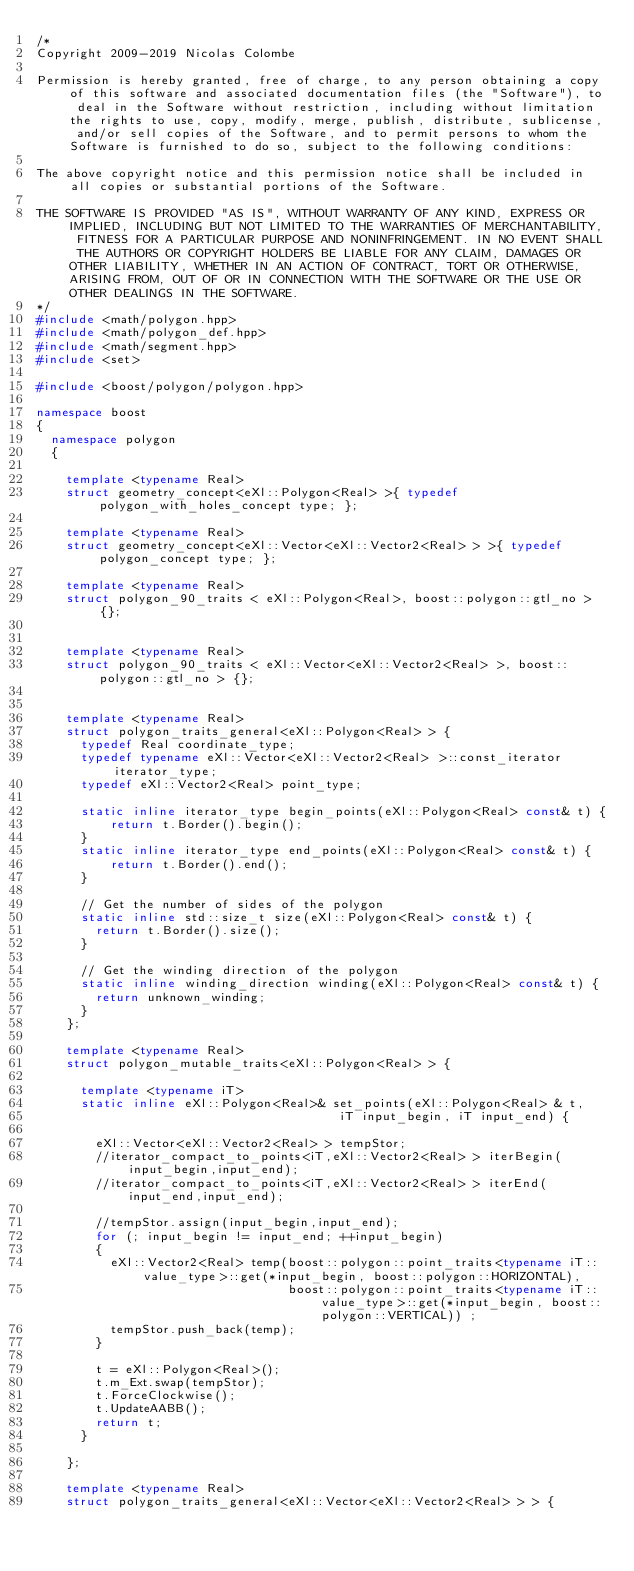Convert code to text. <code><loc_0><loc_0><loc_500><loc_500><_C++_>/*
Copyright 2009-2019 Nicolas Colombe

Permission is hereby granted, free of charge, to any person obtaining a copy of this software and associated documentation files (the "Software"), to deal in the Software without restriction, including without limitation the rights to use, copy, modify, merge, publish, distribute, sublicense, and/or sell copies of the Software, and to permit persons to whom the Software is furnished to do so, subject to the following conditions:

The above copyright notice and this permission notice shall be included in all copies or substantial portions of the Software.

THE SOFTWARE IS PROVIDED "AS IS", WITHOUT WARRANTY OF ANY KIND, EXPRESS OR IMPLIED, INCLUDING BUT NOT LIMITED TO THE WARRANTIES OF MERCHANTABILITY, FITNESS FOR A PARTICULAR PURPOSE AND NONINFRINGEMENT. IN NO EVENT SHALL THE AUTHORS OR COPYRIGHT HOLDERS BE LIABLE FOR ANY CLAIM, DAMAGES OR OTHER LIABILITY, WHETHER IN AN ACTION OF CONTRACT, TORT OR OTHERWISE, ARISING FROM, OUT OF OR IN CONNECTION WITH THE SOFTWARE OR THE USE OR OTHER DEALINGS IN THE SOFTWARE.
*/
#include <math/polygon.hpp>
#include <math/polygon_def.hpp>
#include <math/segment.hpp>
#include <set>

#include <boost/polygon/polygon.hpp>

namespace boost
{
  namespace polygon 
  {
  
    template <typename Real>
    struct geometry_concept<eXl::Polygon<Real> >{ typedef polygon_with_holes_concept type; };
  
    template <typename Real>
    struct geometry_concept<eXl::Vector<eXl::Vector2<Real> > >{ typedef polygon_concept type; };
  
    template <typename Real>
    struct polygon_90_traits < eXl::Polygon<Real>, boost::polygon::gtl_no > {};
    
  
    template <typename Real>
    struct polygon_90_traits < eXl::Vector<eXl::Vector2<Real> >, boost::polygon::gtl_no > {};
    
  
    template <typename Real>
    struct polygon_traits_general<eXl::Polygon<Real> > {
      typedef Real coordinate_type;
      typedef typename eXl::Vector<eXl::Vector2<Real> >::const_iterator iterator_type;
      typedef eXl::Vector2<Real> point_type;
    
      static inline iterator_type begin_points(eXl::Polygon<Real> const& t) {
          return t.Border().begin();
      }
      static inline iterator_type end_points(eXl::Polygon<Real> const& t) {
          return t.Border().end();
      }
    
      // Get the number of sides of the polygon
      static inline std::size_t size(eXl::Polygon<Real> const& t) {
        return t.Border().size();
      }
    
      // Get the winding direction of the polygon
      static inline winding_direction winding(eXl::Polygon<Real> const& t) {
        return unknown_winding;
      }
    };
    
    template <typename Real>
    struct polygon_mutable_traits<eXl::Polygon<Real> > {
    
      template <typename iT>
      static inline eXl::Polygon<Real>& set_points(eXl::Polygon<Real> & t, 
                                         iT input_begin, iT input_end) {
    
        eXl::Vector<eXl::Vector2<Real> > tempStor;
        //iterator_compact_to_points<iT,eXl::Vector2<Real> > iterBegin(input_begin,input_end);
        //iterator_compact_to_points<iT,eXl::Vector2<Real> > iterEnd(input_end,input_end);
        
        //tempStor.assign(input_begin,input_end);
        for (; input_begin != input_end; ++input_begin)
        {
          eXl::Vector2<Real> temp(boost::polygon::point_traits<typename iT::value_type>::get(*input_begin, boost::polygon::HORIZONTAL),
                                  boost::polygon::point_traits<typename iT::value_type>::get(*input_begin, boost::polygon::VERTICAL)) ;
          tempStor.push_back(temp);
        }
    
        t = eXl::Polygon<Real>();
        t.m_Ext.swap(tempStor);
        t.ForceClockwise();
        t.UpdateAABB();
        return t;
      }
    
    };
  
    template <typename Real>
    struct polygon_traits_general<eXl::Vector<eXl::Vector2<Real> > > {</code> 